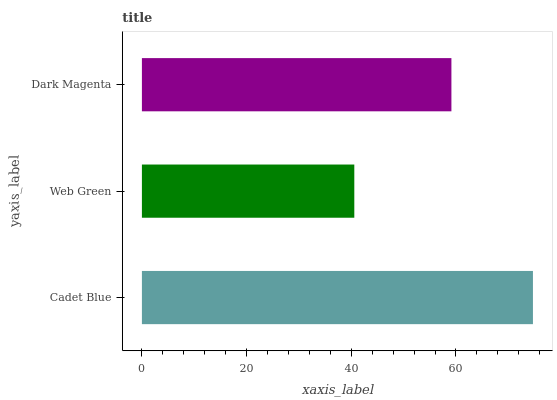Is Web Green the minimum?
Answer yes or no. Yes. Is Cadet Blue the maximum?
Answer yes or no. Yes. Is Dark Magenta the minimum?
Answer yes or no. No. Is Dark Magenta the maximum?
Answer yes or no. No. Is Dark Magenta greater than Web Green?
Answer yes or no. Yes. Is Web Green less than Dark Magenta?
Answer yes or no. Yes. Is Web Green greater than Dark Magenta?
Answer yes or no. No. Is Dark Magenta less than Web Green?
Answer yes or no. No. Is Dark Magenta the high median?
Answer yes or no. Yes. Is Dark Magenta the low median?
Answer yes or no. Yes. Is Web Green the high median?
Answer yes or no. No. Is Web Green the low median?
Answer yes or no. No. 